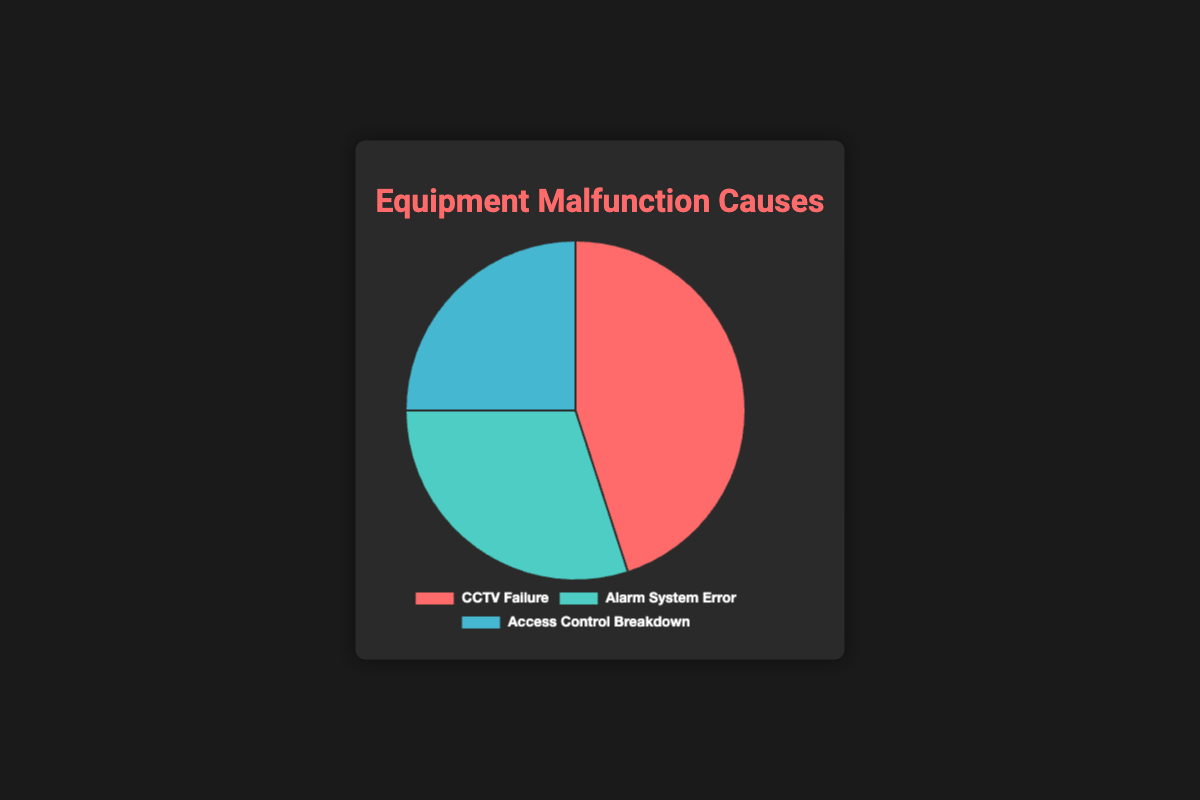What is the cause with the highest percentage of equipment malfunctions? The cause with the highest percentage of equipment malfunctions can be identified by looking at the segment with the largest proportion in the pie chart. The "CCTV Failure" segment occupies the largest area, indicating that it has the highest percentage.
Answer: CCTV Failure What percentage of equipment malfunctions are due to Alarm System Error and Access Control Breakdown combined? To find the combined percentage, add the percentages of "Alarm System Error" and "Access Control Breakdown". According to the data, Alarm System Error is 30% and Access Control Breakdown is 25%. Adding these gives 30% + 25% = 55%.
Answer: 55% Which malfunction cause has the smallest percentage? To identify the cause with the smallest percentage, we look for the segment in the pie chart occupying the least area. "Access Control Breakdown" occupies the smallest slice, indicating it has the smallest percentage.
Answer: Access Control Breakdown How much larger is the percentage for CCTV Failure compared to Access Control Breakdown? To find how much larger the percentage for CCTV Failure is compared to Access Control Breakdown, subtract the percentage of Access Control Breakdown from CCTV Failure. CCTV Failure is 45% and Access Control Breakdown is 25%. So, 45% - 25% = 20%.
Answer: 20% What is the difference in percentage between Alarm System Error and Access Control Breakdown? The difference can be calculated by subtracting the smaller percentage (Access Control Breakdown) from the larger percentage (Alarm System Error). Alarm System Error is 30% and Access Control Breakdown is 25%. Thus, 30% - 25% = 5%.
Answer: 5% Which malfunction cause is represented by the green-colored section of the pie chart? According to the visual attributes in the pie chart, the "Alarm System Error" section is represented by the green color.
Answer: Alarm System Error How does the percentage of Alarm System Error compare to the percentage of CCTV Failure? We compare the percentage of Alarm System Error (30%) to CCTV Failure (45%). Since 30% is less than 45%, Alarm System Error has a lower percentage compared to CCTV Failure.
Answer: Less If the percentage of Access Control Breakdown increased by 10%, what would the new percentage be? To find the new percentage for Access Control Breakdown if it increased by 10%, add 10% to the current percentage (25%). Thus, 25% + 10% = 35%.
Answer: 35% What is the total percentage represented in the pie chart? The total percentage represented in any pie chart always sums up to 100%. This pie chart is divided into segments representing CCTV Failure, Alarm System Error, and Access Control Breakdown, whose combined percentages should sum to 100%.
Answer: 100% 